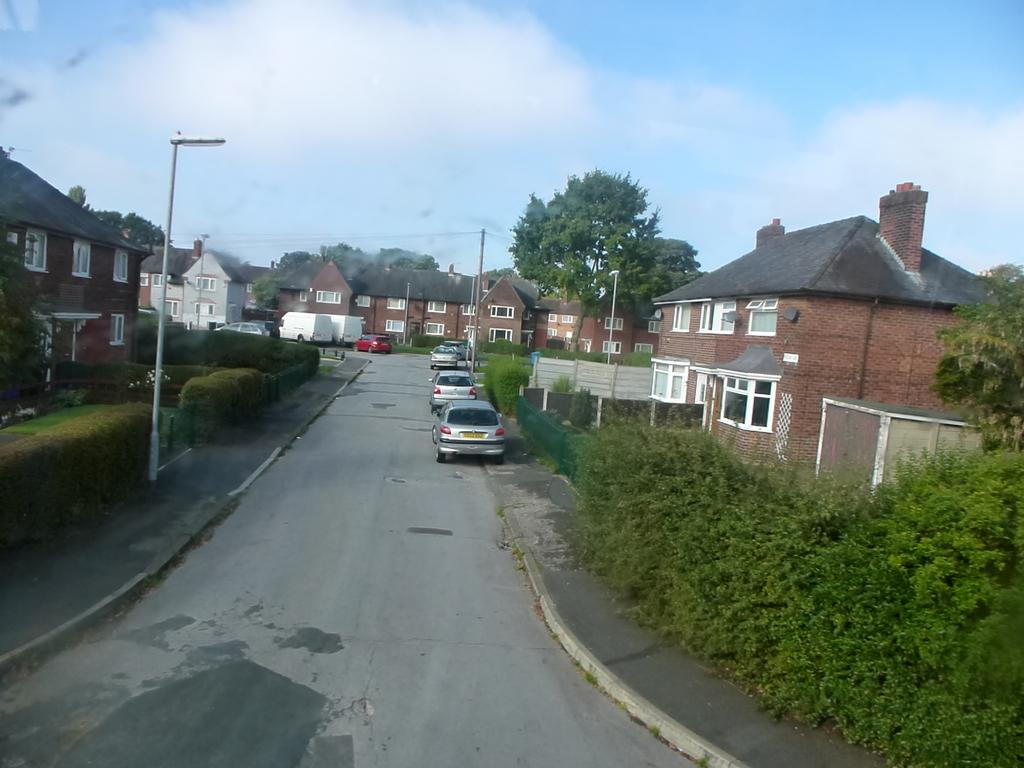What type of structures can be seen in the image? There are buildings in the image. What other natural elements are present in the image? There are trees in the image. What are the vertical structures in the image used for? There are poles in the image, which are likely used for supporting power lines or other utilities. What type of transportation is visible in the image? There are cars and vehicles parked in the image. How would you describe the weather in the image? The sky is blue and cloudy in the image, suggesting a partly cloudy day. What type of fuel is being used by the trees in the image? Trees do not use fuel; they produce their own energy through photosynthesis. There is no indication in the image that the trees are using any type of fuel. 